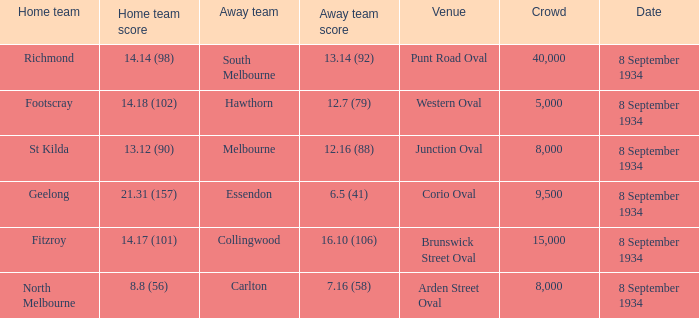When the Venue was Punt Road Oval, who was the Home Team? Richmond. 